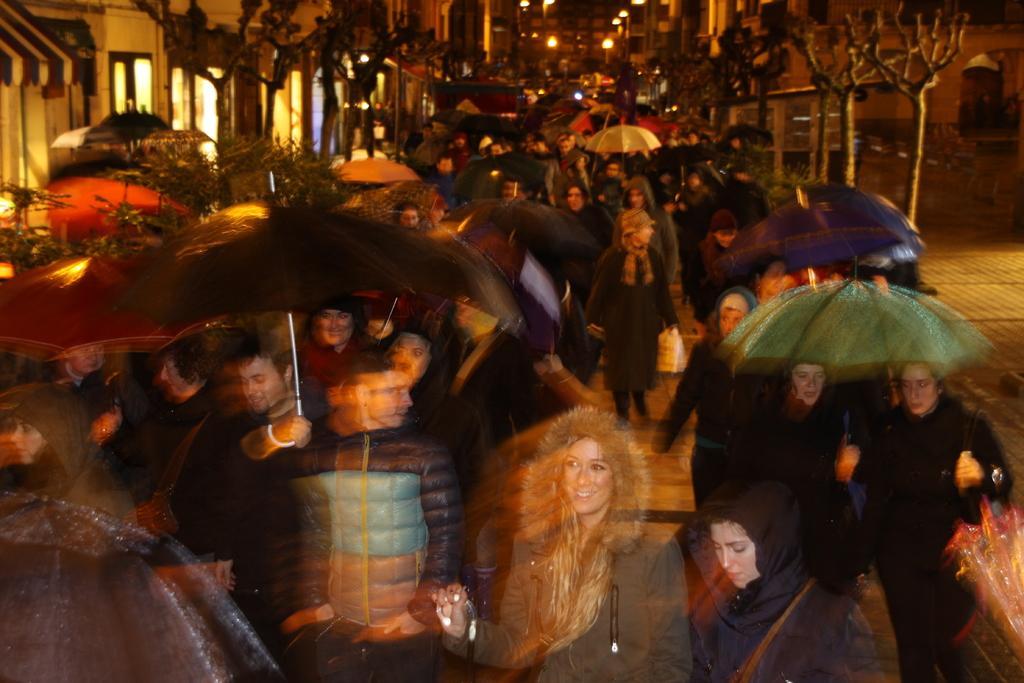How would you summarize this image in a sentence or two? There are groups of people standing. Among them few people are holding the umbrellas. These are the trees. I can see the buildings. 